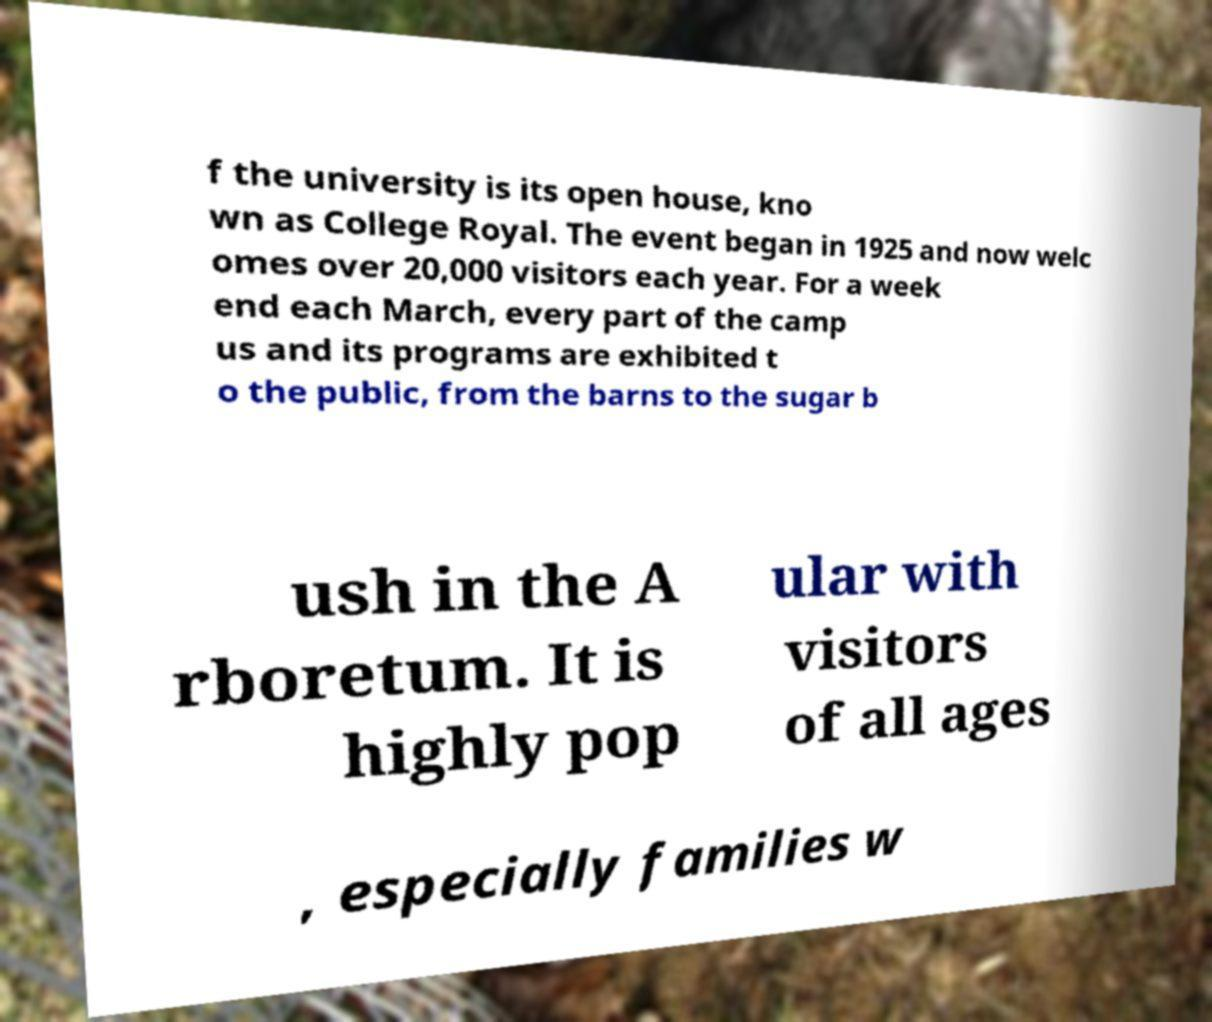Please read and relay the text visible in this image. What does it say? f the university is its open house, kno wn as College Royal. The event began in 1925 and now welc omes over 20,000 visitors each year. For a week end each March, every part of the camp us and its programs are exhibited t o the public, from the barns to the sugar b ush in the A rboretum. It is highly pop ular with visitors of all ages , especially families w 